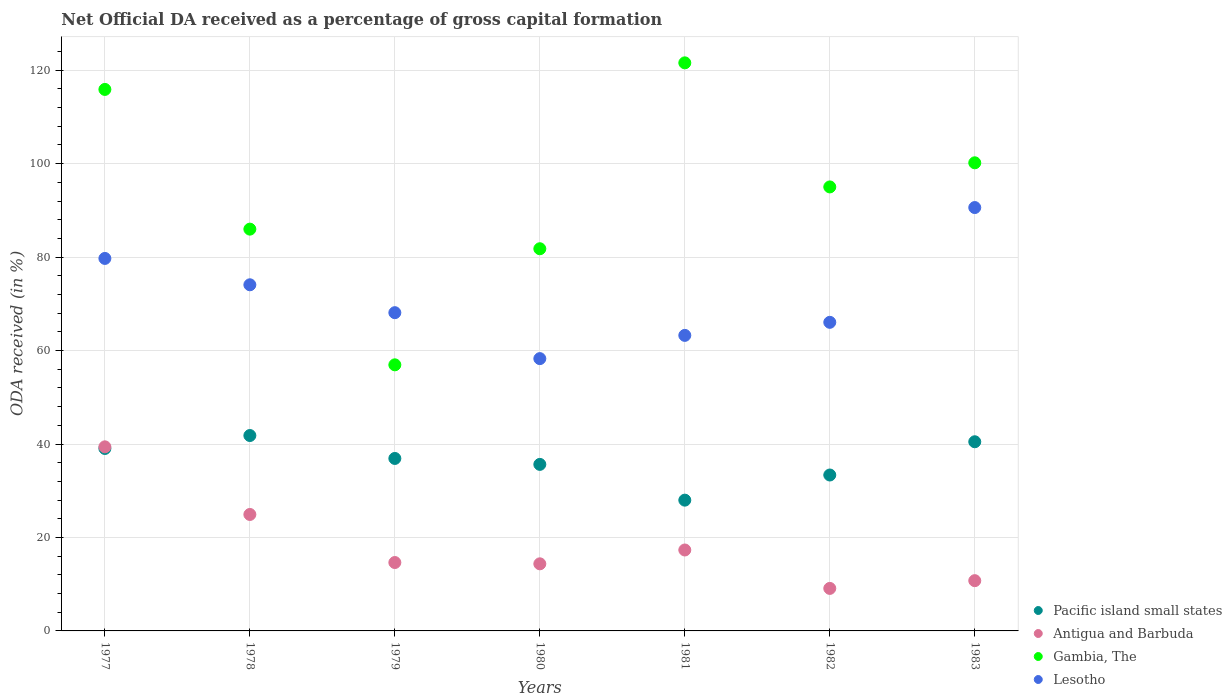What is the net ODA received in Antigua and Barbuda in 1979?
Provide a succinct answer. 14.64. Across all years, what is the maximum net ODA received in Lesotho?
Make the answer very short. 90.61. Across all years, what is the minimum net ODA received in Gambia, The?
Provide a short and direct response. 56.95. In which year was the net ODA received in Lesotho minimum?
Give a very brief answer. 1980. What is the total net ODA received in Pacific island small states in the graph?
Give a very brief answer. 255.25. What is the difference between the net ODA received in Lesotho in 1977 and that in 1980?
Keep it short and to the point. 21.44. What is the difference between the net ODA received in Lesotho in 1983 and the net ODA received in Gambia, The in 1982?
Give a very brief answer. -4.42. What is the average net ODA received in Pacific island small states per year?
Keep it short and to the point. 36.46. In the year 1980, what is the difference between the net ODA received in Lesotho and net ODA received in Pacific island small states?
Offer a very short reply. 22.64. What is the ratio of the net ODA received in Lesotho in 1978 to that in 1983?
Your answer should be compact. 0.82. What is the difference between the highest and the second highest net ODA received in Pacific island small states?
Your response must be concise. 1.33. What is the difference between the highest and the lowest net ODA received in Antigua and Barbuda?
Your response must be concise. 30.3. Is it the case that in every year, the sum of the net ODA received in Pacific island small states and net ODA received in Antigua and Barbuda  is greater than the sum of net ODA received in Gambia, The and net ODA received in Lesotho?
Provide a short and direct response. No. Is it the case that in every year, the sum of the net ODA received in Lesotho and net ODA received in Gambia, The  is greater than the net ODA received in Antigua and Barbuda?
Offer a very short reply. Yes. How many dotlines are there?
Keep it short and to the point. 4. What is the difference between two consecutive major ticks on the Y-axis?
Offer a terse response. 20. Are the values on the major ticks of Y-axis written in scientific E-notation?
Your answer should be very brief. No. Does the graph contain any zero values?
Your response must be concise. No. Where does the legend appear in the graph?
Give a very brief answer. Bottom right. How are the legend labels stacked?
Offer a terse response. Vertical. What is the title of the graph?
Offer a terse response. Net Official DA received as a percentage of gross capital formation. Does "Virgin Islands" appear as one of the legend labels in the graph?
Provide a short and direct response. No. What is the label or title of the Y-axis?
Provide a succinct answer. ODA received (in %). What is the ODA received (in %) of Pacific island small states in 1977?
Your response must be concise. 39.05. What is the ODA received (in %) in Antigua and Barbuda in 1977?
Your answer should be very brief. 39.4. What is the ODA received (in %) of Gambia, The in 1977?
Make the answer very short. 115.89. What is the ODA received (in %) in Lesotho in 1977?
Make the answer very short. 79.72. What is the ODA received (in %) of Pacific island small states in 1978?
Ensure brevity in your answer.  41.82. What is the ODA received (in %) of Antigua and Barbuda in 1978?
Offer a terse response. 24.92. What is the ODA received (in %) in Gambia, The in 1978?
Give a very brief answer. 85.99. What is the ODA received (in %) of Lesotho in 1978?
Your answer should be very brief. 74.08. What is the ODA received (in %) in Pacific island small states in 1979?
Keep it short and to the point. 36.91. What is the ODA received (in %) in Antigua and Barbuda in 1979?
Provide a short and direct response. 14.64. What is the ODA received (in %) in Gambia, The in 1979?
Offer a terse response. 56.95. What is the ODA received (in %) in Lesotho in 1979?
Make the answer very short. 68.11. What is the ODA received (in %) of Pacific island small states in 1980?
Keep it short and to the point. 35.64. What is the ODA received (in %) in Antigua and Barbuda in 1980?
Make the answer very short. 14.36. What is the ODA received (in %) in Gambia, The in 1980?
Offer a very short reply. 81.79. What is the ODA received (in %) in Lesotho in 1980?
Make the answer very short. 58.28. What is the ODA received (in %) in Pacific island small states in 1981?
Your answer should be compact. 27.99. What is the ODA received (in %) of Antigua and Barbuda in 1981?
Your answer should be very brief. 17.32. What is the ODA received (in %) in Gambia, The in 1981?
Make the answer very short. 121.58. What is the ODA received (in %) in Lesotho in 1981?
Keep it short and to the point. 63.25. What is the ODA received (in %) in Pacific island small states in 1982?
Make the answer very short. 33.37. What is the ODA received (in %) of Antigua and Barbuda in 1982?
Your answer should be very brief. 9.1. What is the ODA received (in %) in Gambia, The in 1982?
Ensure brevity in your answer.  95.02. What is the ODA received (in %) in Lesotho in 1982?
Your answer should be very brief. 66.04. What is the ODA received (in %) in Pacific island small states in 1983?
Keep it short and to the point. 40.48. What is the ODA received (in %) of Antigua and Barbuda in 1983?
Provide a succinct answer. 10.76. What is the ODA received (in %) of Gambia, The in 1983?
Your answer should be very brief. 100.18. What is the ODA received (in %) of Lesotho in 1983?
Make the answer very short. 90.61. Across all years, what is the maximum ODA received (in %) of Pacific island small states?
Provide a short and direct response. 41.82. Across all years, what is the maximum ODA received (in %) of Antigua and Barbuda?
Offer a terse response. 39.4. Across all years, what is the maximum ODA received (in %) of Gambia, The?
Provide a short and direct response. 121.58. Across all years, what is the maximum ODA received (in %) in Lesotho?
Keep it short and to the point. 90.61. Across all years, what is the minimum ODA received (in %) in Pacific island small states?
Your response must be concise. 27.99. Across all years, what is the minimum ODA received (in %) in Antigua and Barbuda?
Provide a short and direct response. 9.1. Across all years, what is the minimum ODA received (in %) of Gambia, The?
Provide a short and direct response. 56.95. Across all years, what is the minimum ODA received (in %) of Lesotho?
Your answer should be compact. 58.28. What is the total ODA received (in %) in Pacific island small states in the graph?
Keep it short and to the point. 255.25. What is the total ODA received (in %) in Antigua and Barbuda in the graph?
Ensure brevity in your answer.  130.49. What is the total ODA received (in %) of Gambia, The in the graph?
Your answer should be very brief. 657.4. What is the total ODA received (in %) of Lesotho in the graph?
Offer a very short reply. 500.08. What is the difference between the ODA received (in %) in Pacific island small states in 1977 and that in 1978?
Make the answer very short. -2.77. What is the difference between the ODA received (in %) of Antigua and Barbuda in 1977 and that in 1978?
Your answer should be compact. 14.47. What is the difference between the ODA received (in %) in Gambia, The in 1977 and that in 1978?
Ensure brevity in your answer.  29.9. What is the difference between the ODA received (in %) in Lesotho in 1977 and that in 1978?
Offer a very short reply. 5.64. What is the difference between the ODA received (in %) of Pacific island small states in 1977 and that in 1979?
Make the answer very short. 2.14. What is the difference between the ODA received (in %) in Antigua and Barbuda in 1977 and that in 1979?
Your answer should be compact. 24.76. What is the difference between the ODA received (in %) in Gambia, The in 1977 and that in 1979?
Keep it short and to the point. 58.94. What is the difference between the ODA received (in %) in Lesotho in 1977 and that in 1979?
Make the answer very short. 11.61. What is the difference between the ODA received (in %) of Pacific island small states in 1977 and that in 1980?
Your answer should be very brief. 3.41. What is the difference between the ODA received (in %) in Antigua and Barbuda in 1977 and that in 1980?
Offer a very short reply. 25.04. What is the difference between the ODA received (in %) in Gambia, The in 1977 and that in 1980?
Offer a terse response. 34.1. What is the difference between the ODA received (in %) in Lesotho in 1977 and that in 1980?
Your answer should be compact. 21.44. What is the difference between the ODA received (in %) of Pacific island small states in 1977 and that in 1981?
Make the answer very short. 11.06. What is the difference between the ODA received (in %) in Antigua and Barbuda in 1977 and that in 1981?
Your answer should be compact. 22.08. What is the difference between the ODA received (in %) of Gambia, The in 1977 and that in 1981?
Your response must be concise. -5.69. What is the difference between the ODA received (in %) in Lesotho in 1977 and that in 1981?
Ensure brevity in your answer.  16.47. What is the difference between the ODA received (in %) of Pacific island small states in 1977 and that in 1982?
Give a very brief answer. 5.68. What is the difference between the ODA received (in %) in Antigua and Barbuda in 1977 and that in 1982?
Make the answer very short. 30.3. What is the difference between the ODA received (in %) in Gambia, The in 1977 and that in 1982?
Offer a terse response. 20.87. What is the difference between the ODA received (in %) of Lesotho in 1977 and that in 1982?
Give a very brief answer. 13.67. What is the difference between the ODA received (in %) in Pacific island small states in 1977 and that in 1983?
Your answer should be compact. -1.44. What is the difference between the ODA received (in %) in Antigua and Barbuda in 1977 and that in 1983?
Your answer should be compact. 28.64. What is the difference between the ODA received (in %) in Gambia, The in 1977 and that in 1983?
Your answer should be compact. 15.7. What is the difference between the ODA received (in %) of Lesotho in 1977 and that in 1983?
Provide a succinct answer. -10.89. What is the difference between the ODA received (in %) in Pacific island small states in 1978 and that in 1979?
Your answer should be compact. 4.91. What is the difference between the ODA received (in %) of Antigua and Barbuda in 1978 and that in 1979?
Your response must be concise. 10.29. What is the difference between the ODA received (in %) of Gambia, The in 1978 and that in 1979?
Your answer should be compact. 29.04. What is the difference between the ODA received (in %) in Lesotho in 1978 and that in 1979?
Give a very brief answer. 5.97. What is the difference between the ODA received (in %) in Pacific island small states in 1978 and that in 1980?
Provide a short and direct response. 6.18. What is the difference between the ODA received (in %) of Antigua and Barbuda in 1978 and that in 1980?
Provide a succinct answer. 10.56. What is the difference between the ODA received (in %) of Gambia, The in 1978 and that in 1980?
Provide a succinct answer. 4.2. What is the difference between the ODA received (in %) of Lesotho in 1978 and that in 1980?
Provide a succinct answer. 15.8. What is the difference between the ODA received (in %) of Pacific island small states in 1978 and that in 1981?
Provide a short and direct response. 13.83. What is the difference between the ODA received (in %) of Antigua and Barbuda in 1978 and that in 1981?
Ensure brevity in your answer.  7.6. What is the difference between the ODA received (in %) in Gambia, The in 1978 and that in 1981?
Ensure brevity in your answer.  -35.59. What is the difference between the ODA received (in %) in Lesotho in 1978 and that in 1981?
Provide a succinct answer. 10.83. What is the difference between the ODA received (in %) in Pacific island small states in 1978 and that in 1982?
Ensure brevity in your answer.  8.45. What is the difference between the ODA received (in %) in Antigua and Barbuda in 1978 and that in 1982?
Your response must be concise. 15.83. What is the difference between the ODA received (in %) of Gambia, The in 1978 and that in 1982?
Ensure brevity in your answer.  -9.03. What is the difference between the ODA received (in %) in Lesotho in 1978 and that in 1982?
Offer a terse response. 8.03. What is the difference between the ODA received (in %) of Pacific island small states in 1978 and that in 1983?
Offer a very short reply. 1.33. What is the difference between the ODA received (in %) in Antigua and Barbuda in 1978 and that in 1983?
Provide a succinct answer. 14.17. What is the difference between the ODA received (in %) of Gambia, The in 1978 and that in 1983?
Your answer should be compact. -14.2. What is the difference between the ODA received (in %) in Lesotho in 1978 and that in 1983?
Give a very brief answer. -16.53. What is the difference between the ODA received (in %) of Pacific island small states in 1979 and that in 1980?
Your answer should be very brief. 1.27. What is the difference between the ODA received (in %) of Antigua and Barbuda in 1979 and that in 1980?
Your answer should be very brief. 0.28. What is the difference between the ODA received (in %) of Gambia, The in 1979 and that in 1980?
Offer a terse response. -24.84. What is the difference between the ODA received (in %) in Lesotho in 1979 and that in 1980?
Offer a very short reply. 9.83. What is the difference between the ODA received (in %) of Pacific island small states in 1979 and that in 1981?
Make the answer very short. 8.92. What is the difference between the ODA received (in %) of Antigua and Barbuda in 1979 and that in 1981?
Offer a terse response. -2.68. What is the difference between the ODA received (in %) in Gambia, The in 1979 and that in 1981?
Provide a succinct answer. -64.63. What is the difference between the ODA received (in %) of Lesotho in 1979 and that in 1981?
Offer a terse response. 4.86. What is the difference between the ODA received (in %) in Pacific island small states in 1979 and that in 1982?
Your response must be concise. 3.54. What is the difference between the ODA received (in %) of Antigua and Barbuda in 1979 and that in 1982?
Ensure brevity in your answer.  5.54. What is the difference between the ODA received (in %) of Gambia, The in 1979 and that in 1982?
Offer a very short reply. -38.07. What is the difference between the ODA received (in %) of Lesotho in 1979 and that in 1982?
Your answer should be compact. 2.07. What is the difference between the ODA received (in %) of Pacific island small states in 1979 and that in 1983?
Offer a very short reply. -3.57. What is the difference between the ODA received (in %) of Antigua and Barbuda in 1979 and that in 1983?
Provide a succinct answer. 3.88. What is the difference between the ODA received (in %) of Gambia, The in 1979 and that in 1983?
Your answer should be very brief. -43.24. What is the difference between the ODA received (in %) of Lesotho in 1979 and that in 1983?
Provide a succinct answer. -22.5. What is the difference between the ODA received (in %) of Pacific island small states in 1980 and that in 1981?
Make the answer very short. 7.65. What is the difference between the ODA received (in %) in Antigua and Barbuda in 1980 and that in 1981?
Your response must be concise. -2.96. What is the difference between the ODA received (in %) in Gambia, The in 1980 and that in 1981?
Your answer should be very brief. -39.78. What is the difference between the ODA received (in %) of Lesotho in 1980 and that in 1981?
Your response must be concise. -4.97. What is the difference between the ODA received (in %) of Pacific island small states in 1980 and that in 1982?
Your answer should be compact. 2.27. What is the difference between the ODA received (in %) in Antigua and Barbuda in 1980 and that in 1982?
Make the answer very short. 5.26. What is the difference between the ODA received (in %) in Gambia, The in 1980 and that in 1982?
Provide a short and direct response. -13.23. What is the difference between the ODA received (in %) of Lesotho in 1980 and that in 1982?
Ensure brevity in your answer.  -7.77. What is the difference between the ODA received (in %) in Pacific island small states in 1980 and that in 1983?
Your answer should be very brief. -4.84. What is the difference between the ODA received (in %) of Antigua and Barbuda in 1980 and that in 1983?
Provide a succinct answer. 3.61. What is the difference between the ODA received (in %) in Gambia, The in 1980 and that in 1983?
Provide a short and direct response. -18.39. What is the difference between the ODA received (in %) of Lesotho in 1980 and that in 1983?
Give a very brief answer. -32.33. What is the difference between the ODA received (in %) of Pacific island small states in 1981 and that in 1982?
Your answer should be very brief. -5.38. What is the difference between the ODA received (in %) of Antigua and Barbuda in 1981 and that in 1982?
Ensure brevity in your answer.  8.22. What is the difference between the ODA received (in %) in Gambia, The in 1981 and that in 1982?
Provide a succinct answer. 26.55. What is the difference between the ODA received (in %) of Lesotho in 1981 and that in 1982?
Ensure brevity in your answer.  -2.8. What is the difference between the ODA received (in %) of Pacific island small states in 1981 and that in 1983?
Offer a terse response. -12.5. What is the difference between the ODA received (in %) of Antigua and Barbuda in 1981 and that in 1983?
Offer a very short reply. 6.57. What is the difference between the ODA received (in %) in Gambia, The in 1981 and that in 1983?
Your answer should be compact. 21.39. What is the difference between the ODA received (in %) in Lesotho in 1981 and that in 1983?
Offer a very short reply. -27.36. What is the difference between the ODA received (in %) in Pacific island small states in 1982 and that in 1983?
Keep it short and to the point. -7.11. What is the difference between the ODA received (in %) of Antigua and Barbuda in 1982 and that in 1983?
Offer a terse response. -1.66. What is the difference between the ODA received (in %) of Gambia, The in 1982 and that in 1983?
Your answer should be compact. -5.16. What is the difference between the ODA received (in %) in Lesotho in 1982 and that in 1983?
Keep it short and to the point. -24.56. What is the difference between the ODA received (in %) in Pacific island small states in 1977 and the ODA received (in %) in Antigua and Barbuda in 1978?
Your response must be concise. 14.12. What is the difference between the ODA received (in %) of Pacific island small states in 1977 and the ODA received (in %) of Gambia, The in 1978?
Offer a very short reply. -46.94. What is the difference between the ODA received (in %) of Pacific island small states in 1977 and the ODA received (in %) of Lesotho in 1978?
Your answer should be very brief. -35.03. What is the difference between the ODA received (in %) of Antigua and Barbuda in 1977 and the ODA received (in %) of Gambia, The in 1978?
Provide a succinct answer. -46.59. What is the difference between the ODA received (in %) of Antigua and Barbuda in 1977 and the ODA received (in %) of Lesotho in 1978?
Your answer should be very brief. -34.68. What is the difference between the ODA received (in %) in Gambia, The in 1977 and the ODA received (in %) in Lesotho in 1978?
Provide a succinct answer. 41.81. What is the difference between the ODA received (in %) in Pacific island small states in 1977 and the ODA received (in %) in Antigua and Barbuda in 1979?
Your response must be concise. 24.41. What is the difference between the ODA received (in %) in Pacific island small states in 1977 and the ODA received (in %) in Gambia, The in 1979?
Provide a succinct answer. -17.9. What is the difference between the ODA received (in %) in Pacific island small states in 1977 and the ODA received (in %) in Lesotho in 1979?
Provide a succinct answer. -29.06. What is the difference between the ODA received (in %) of Antigua and Barbuda in 1977 and the ODA received (in %) of Gambia, The in 1979?
Make the answer very short. -17.55. What is the difference between the ODA received (in %) of Antigua and Barbuda in 1977 and the ODA received (in %) of Lesotho in 1979?
Make the answer very short. -28.71. What is the difference between the ODA received (in %) of Gambia, The in 1977 and the ODA received (in %) of Lesotho in 1979?
Your response must be concise. 47.78. What is the difference between the ODA received (in %) of Pacific island small states in 1977 and the ODA received (in %) of Antigua and Barbuda in 1980?
Provide a succinct answer. 24.69. What is the difference between the ODA received (in %) of Pacific island small states in 1977 and the ODA received (in %) of Gambia, The in 1980?
Offer a terse response. -42.75. What is the difference between the ODA received (in %) in Pacific island small states in 1977 and the ODA received (in %) in Lesotho in 1980?
Your answer should be compact. -19.23. What is the difference between the ODA received (in %) in Antigua and Barbuda in 1977 and the ODA received (in %) in Gambia, The in 1980?
Keep it short and to the point. -42.39. What is the difference between the ODA received (in %) of Antigua and Barbuda in 1977 and the ODA received (in %) of Lesotho in 1980?
Your answer should be compact. -18.88. What is the difference between the ODA received (in %) in Gambia, The in 1977 and the ODA received (in %) in Lesotho in 1980?
Offer a terse response. 57.61. What is the difference between the ODA received (in %) of Pacific island small states in 1977 and the ODA received (in %) of Antigua and Barbuda in 1981?
Your answer should be very brief. 21.73. What is the difference between the ODA received (in %) in Pacific island small states in 1977 and the ODA received (in %) in Gambia, The in 1981?
Make the answer very short. -82.53. What is the difference between the ODA received (in %) in Pacific island small states in 1977 and the ODA received (in %) in Lesotho in 1981?
Provide a short and direct response. -24.2. What is the difference between the ODA received (in %) in Antigua and Barbuda in 1977 and the ODA received (in %) in Gambia, The in 1981?
Make the answer very short. -82.18. What is the difference between the ODA received (in %) of Antigua and Barbuda in 1977 and the ODA received (in %) of Lesotho in 1981?
Give a very brief answer. -23.85. What is the difference between the ODA received (in %) in Gambia, The in 1977 and the ODA received (in %) in Lesotho in 1981?
Provide a short and direct response. 52.64. What is the difference between the ODA received (in %) of Pacific island small states in 1977 and the ODA received (in %) of Antigua and Barbuda in 1982?
Provide a short and direct response. 29.95. What is the difference between the ODA received (in %) of Pacific island small states in 1977 and the ODA received (in %) of Gambia, The in 1982?
Make the answer very short. -55.98. What is the difference between the ODA received (in %) in Pacific island small states in 1977 and the ODA received (in %) in Lesotho in 1982?
Offer a terse response. -27. What is the difference between the ODA received (in %) in Antigua and Barbuda in 1977 and the ODA received (in %) in Gambia, The in 1982?
Your answer should be very brief. -55.62. What is the difference between the ODA received (in %) in Antigua and Barbuda in 1977 and the ODA received (in %) in Lesotho in 1982?
Provide a short and direct response. -26.65. What is the difference between the ODA received (in %) of Gambia, The in 1977 and the ODA received (in %) of Lesotho in 1982?
Provide a short and direct response. 49.84. What is the difference between the ODA received (in %) in Pacific island small states in 1977 and the ODA received (in %) in Antigua and Barbuda in 1983?
Make the answer very short. 28.29. What is the difference between the ODA received (in %) in Pacific island small states in 1977 and the ODA received (in %) in Gambia, The in 1983?
Offer a very short reply. -61.14. What is the difference between the ODA received (in %) in Pacific island small states in 1977 and the ODA received (in %) in Lesotho in 1983?
Your answer should be compact. -51.56. What is the difference between the ODA received (in %) of Antigua and Barbuda in 1977 and the ODA received (in %) of Gambia, The in 1983?
Your answer should be compact. -60.79. What is the difference between the ODA received (in %) of Antigua and Barbuda in 1977 and the ODA received (in %) of Lesotho in 1983?
Give a very brief answer. -51.21. What is the difference between the ODA received (in %) of Gambia, The in 1977 and the ODA received (in %) of Lesotho in 1983?
Provide a short and direct response. 25.28. What is the difference between the ODA received (in %) in Pacific island small states in 1978 and the ODA received (in %) in Antigua and Barbuda in 1979?
Your answer should be very brief. 27.18. What is the difference between the ODA received (in %) of Pacific island small states in 1978 and the ODA received (in %) of Gambia, The in 1979?
Ensure brevity in your answer.  -15.13. What is the difference between the ODA received (in %) of Pacific island small states in 1978 and the ODA received (in %) of Lesotho in 1979?
Offer a very short reply. -26.29. What is the difference between the ODA received (in %) of Antigua and Barbuda in 1978 and the ODA received (in %) of Gambia, The in 1979?
Make the answer very short. -32.02. What is the difference between the ODA received (in %) of Antigua and Barbuda in 1978 and the ODA received (in %) of Lesotho in 1979?
Provide a short and direct response. -43.19. What is the difference between the ODA received (in %) in Gambia, The in 1978 and the ODA received (in %) in Lesotho in 1979?
Offer a terse response. 17.88. What is the difference between the ODA received (in %) in Pacific island small states in 1978 and the ODA received (in %) in Antigua and Barbuda in 1980?
Offer a terse response. 27.46. What is the difference between the ODA received (in %) of Pacific island small states in 1978 and the ODA received (in %) of Gambia, The in 1980?
Your answer should be very brief. -39.97. What is the difference between the ODA received (in %) in Pacific island small states in 1978 and the ODA received (in %) in Lesotho in 1980?
Ensure brevity in your answer.  -16.46. What is the difference between the ODA received (in %) of Antigua and Barbuda in 1978 and the ODA received (in %) of Gambia, The in 1980?
Offer a terse response. -56.87. What is the difference between the ODA received (in %) of Antigua and Barbuda in 1978 and the ODA received (in %) of Lesotho in 1980?
Provide a succinct answer. -33.35. What is the difference between the ODA received (in %) of Gambia, The in 1978 and the ODA received (in %) of Lesotho in 1980?
Make the answer very short. 27.71. What is the difference between the ODA received (in %) in Pacific island small states in 1978 and the ODA received (in %) in Antigua and Barbuda in 1981?
Provide a short and direct response. 24.5. What is the difference between the ODA received (in %) of Pacific island small states in 1978 and the ODA received (in %) of Gambia, The in 1981?
Offer a very short reply. -79.76. What is the difference between the ODA received (in %) of Pacific island small states in 1978 and the ODA received (in %) of Lesotho in 1981?
Make the answer very short. -21.43. What is the difference between the ODA received (in %) in Antigua and Barbuda in 1978 and the ODA received (in %) in Gambia, The in 1981?
Your response must be concise. -96.65. What is the difference between the ODA received (in %) in Antigua and Barbuda in 1978 and the ODA received (in %) in Lesotho in 1981?
Your answer should be compact. -38.33. What is the difference between the ODA received (in %) in Gambia, The in 1978 and the ODA received (in %) in Lesotho in 1981?
Give a very brief answer. 22.74. What is the difference between the ODA received (in %) of Pacific island small states in 1978 and the ODA received (in %) of Antigua and Barbuda in 1982?
Offer a terse response. 32.72. What is the difference between the ODA received (in %) in Pacific island small states in 1978 and the ODA received (in %) in Gambia, The in 1982?
Keep it short and to the point. -53.2. What is the difference between the ODA received (in %) of Pacific island small states in 1978 and the ODA received (in %) of Lesotho in 1982?
Offer a very short reply. -24.23. What is the difference between the ODA received (in %) in Antigua and Barbuda in 1978 and the ODA received (in %) in Gambia, The in 1982?
Your answer should be compact. -70.1. What is the difference between the ODA received (in %) in Antigua and Barbuda in 1978 and the ODA received (in %) in Lesotho in 1982?
Provide a short and direct response. -41.12. What is the difference between the ODA received (in %) in Gambia, The in 1978 and the ODA received (in %) in Lesotho in 1982?
Make the answer very short. 19.94. What is the difference between the ODA received (in %) in Pacific island small states in 1978 and the ODA received (in %) in Antigua and Barbuda in 1983?
Provide a succinct answer. 31.06. What is the difference between the ODA received (in %) of Pacific island small states in 1978 and the ODA received (in %) of Gambia, The in 1983?
Your answer should be very brief. -58.37. What is the difference between the ODA received (in %) in Pacific island small states in 1978 and the ODA received (in %) in Lesotho in 1983?
Provide a short and direct response. -48.79. What is the difference between the ODA received (in %) of Antigua and Barbuda in 1978 and the ODA received (in %) of Gambia, The in 1983?
Provide a succinct answer. -75.26. What is the difference between the ODA received (in %) of Antigua and Barbuda in 1978 and the ODA received (in %) of Lesotho in 1983?
Your answer should be compact. -65.68. What is the difference between the ODA received (in %) of Gambia, The in 1978 and the ODA received (in %) of Lesotho in 1983?
Keep it short and to the point. -4.62. What is the difference between the ODA received (in %) of Pacific island small states in 1979 and the ODA received (in %) of Antigua and Barbuda in 1980?
Make the answer very short. 22.55. What is the difference between the ODA received (in %) in Pacific island small states in 1979 and the ODA received (in %) in Gambia, The in 1980?
Keep it short and to the point. -44.88. What is the difference between the ODA received (in %) in Pacific island small states in 1979 and the ODA received (in %) in Lesotho in 1980?
Make the answer very short. -21.37. What is the difference between the ODA received (in %) in Antigua and Barbuda in 1979 and the ODA received (in %) in Gambia, The in 1980?
Provide a succinct answer. -67.15. What is the difference between the ODA received (in %) in Antigua and Barbuda in 1979 and the ODA received (in %) in Lesotho in 1980?
Keep it short and to the point. -43.64. What is the difference between the ODA received (in %) of Gambia, The in 1979 and the ODA received (in %) of Lesotho in 1980?
Make the answer very short. -1.33. What is the difference between the ODA received (in %) in Pacific island small states in 1979 and the ODA received (in %) in Antigua and Barbuda in 1981?
Provide a succinct answer. 19.59. What is the difference between the ODA received (in %) in Pacific island small states in 1979 and the ODA received (in %) in Gambia, The in 1981?
Make the answer very short. -84.66. What is the difference between the ODA received (in %) in Pacific island small states in 1979 and the ODA received (in %) in Lesotho in 1981?
Provide a succinct answer. -26.34. What is the difference between the ODA received (in %) of Antigua and Barbuda in 1979 and the ODA received (in %) of Gambia, The in 1981?
Keep it short and to the point. -106.94. What is the difference between the ODA received (in %) in Antigua and Barbuda in 1979 and the ODA received (in %) in Lesotho in 1981?
Ensure brevity in your answer.  -48.61. What is the difference between the ODA received (in %) in Gambia, The in 1979 and the ODA received (in %) in Lesotho in 1981?
Your answer should be compact. -6.3. What is the difference between the ODA received (in %) of Pacific island small states in 1979 and the ODA received (in %) of Antigua and Barbuda in 1982?
Keep it short and to the point. 27.81. What is the difference between the ODA received (in %) in Pacific island small states in 1979 and the ODA received (in %) in Gambia, The in 1982?
Your answer should be very brief. -58.11. What is the difference between the ODA received (in %) of Pacific island small states in 1979 and the ODA received (in %) of Lesotho in 1982?
Offer a very short reply. -29.13. What is the difference between the ODA received (in %) of Antigua and Barbuda in 1979 and the ODA received (in %) of Gambia, The in 1982?
Make the answer very short. -80.38. What is the difference between the ODA received (in %) in Antigua and Barbuda in 1979 and the ODA received (in %) in Lesotho in 1982?
Your response must be concise. -51.41. What is the difference between the ODA received (in %) in Gambia, The in 1979 and the ODA received (in %) in Lesotho in 1982?
Provide a short and direct response. -9.1. What is the difference between the ODA received (in %) of Pacific island small states in 1979 and the ODA received (in %) of Antigua and Barbuda in 1983?
Offer a very short reply. 26.16. What is the difference between the ODA received (in %) in Pacific island small states in 1979 and the ODA received (in %) in Gambia, The in 1983?
Offer a terse response. -63.27. What is the difference between the ODA received (in %) in Pacific island small states in 1979 and the ODA received (in %) in Lesotho in 1983?
Your response must be concise. -53.7. What is the difference between the ODA received (in %) in Antigua and Barbuda in 1979 and the ODA received (in %) in Gambia, The in 1983?
Your answer should be very brief. -85.55. What is the difference between the ODA received (in %) of Antigua and Barbuda in 1979 and the ODA received (in %) of Lesotho in 1983?
Ensure brevity in your answer.  -75.97. What is the difference between the ODA received (in %) of Gambia, The in 1979 and the ODA received (in %) of Lesotho in 1983?
Provide a succinct answer. -33.66. What is the difference between the ODA received (in %) in Pacific island small states in 1980 and the ODA received (in %) in Antigua and Barbuda in 1981?
Your answer should be very brief. 18.32. What is the difference between the ODA received (in %) of Pacific island small states in 1980 and the ODA received (in %) of Gambia, The in 1981?
Make the answer very short. -85.94. What is the difference between the ODA received (in %) in Pacific island small states in 1980 and the ODA received (in %) in Lesotho in 1981?
Provide a succinct answer. -27.61. What is the difference between the ODA received (in %) in Antigua and Barbuda in 1980 and the ODA received (in %) in Gambia, The in 1981?
Offer a terse response. -107.21. What is the difference between the ODA received (in %) in Antigua and Barbuda in 1980 and the ODA received (in %) in Lesotho in 1981?
Offer a very short reply. -48.89. What is the difference between the ODA received (in %) of Gambia, The in 1980 and the ODA received (in %) of Lesotho in 1981?
Ensure brevity in your answer.  18.54. What is the difference between the ODA received (in %) in Pacific island small states in 1980 and the ODA received (in %) in Antigua and Barbuda in 1982?
Your answer should be compact. 26.54. What is the difference between the ODA received (in %) in Pacific island small states in 1980 and the ODA received (in %) in Gambia, The in 1982?
Ensure brevity in your answer.  -59.38. What is the difference between the ODA received (in %) in Pacific island small states in 1980 and the ODA received (in %) in Lesotho in 1982?
Keep it short and to the point. -30.4. What is the difference between the ODA received (in %) in Antigua and Barbuda in 1980 and the ODA received (in %) in Gambia, The in 1982?
Offer a very short reply. -80.66. What is the difference between the ODA received (in %) of Antigua and Barbuda in 1980 and the ODA received (in %) of Lesotho in 1982?
Give a very brief answer. -51.68. What is the difference between the ODA received (in %) of Gambia, The in 1980 and the ODA received (in %) of Lesotho in 1982?
Provide a short and direct response. 15.75. What is the difference between the ODA received (in %) in Pacific island small states in 1980 and the ODA received (in %) in Antigua and Barbuda in 1983?
Offer a terse response. 24.88. What is the difference between the ODA received (in %) in Pacific island small states in 1980 and the ODA received (in %) in Gambia, The in 1983?
Your answer should be compact. -64.54. What is the difference between the ODA received (in %) of Pacific island small states in 1980 and the ODA received (in %) of Lesotho in 1983?
Provide a succinct answer. -54.97. What is the difference between the ODA received (in %) of Antigua and Barbuda in 1980 and the ODA received (in %) of Gambia, The in 1983?
Make the answer very short. -85.82. What is the difference between the ODA received (in %) in Antigua and Barbuda in 1980 and the ODA received (in %) in Lesotho in 1983?
Keep it short and to the point. -76.25. What is the difference between the ODA received (in %) in Gambia, The in 1980 and the ODA received (in %) in Lesotho in 1983?
Offer a terse response. -8.81. What is the difference between the ODA received (in %) in Pacific island small states in 1981 and the ODA received (in %) in Antigua and Barbuda in 1982?
Ensure brevity in your answer.  18.89. What is the difference between the ODA received (in %) of Pacific island small states in 1981 and the ODA received (in %) of Gambia, The in 1982?
Keep it short and to the point. -67.03. What is the difference between the ODA received (in %) of Pacific island small states in 1981 and the ODA received (in %) of Lesotho in 1982?
Keep it short and to the point. -38.06. What is the difference between the ODA received (in %) of Antigua and Barbuda in 1981 and the ODA received (in %) of Gambia, The in 1982?
Make the answer very short. -77.7. What is the difference between the ODA received (in %) of Antigua and Barbuda in 1981 and the ODA received (in %) of Lesotho in 1982?
Make the answer very short. -48.72. What is the difference between the ODA received (in %) of Gambia, The in 1981 and the ODA received (in %) of Lesotho in 1982?
Offer a very short reply. 55.53. What is the difference between the ODA received (in %) in Pacific island small states in 1981 and the ODA received (in %) in Antigua and Barbuda in 1983?
Your answer should be very brief. 17.23. What is the difference between the ODA received (in %) in Pacific island small states in 1981 and the ODA received (in %) in Gambia, The in 1983?
Give a very brief answer. -72.2. What is the difference between the ODA received (in %) in Pacific island small states in 1981 and the ODA received (in %) in Lesotho in 1983?
Provide a succinct answer. -62.62. What is the difference between the ODA received (in %) of Antigua and Barbuda in 1981 and the ODA received (in %) of Gambia, The in 1983?
Give a very brief answer. -82.86. What is the difference between the ODA received (in %) in Antigua and Barbuda in 1981 and the ODA received (in %) in Lesotho in 1983?
Give a very brief answer. -73.29. What is the difference between the ODA received (in %) of Gambia, The in 1981 and the ODA received (in %) of Lesotho in 1983?
Give a very brief answer. 30.97. What is the difference between the ODA received (in %) in Pacific island small states in 1982 and the ODA received (in %) in Antigua and Barbuda in 1983?
Offer a terse response. 22.61. What is the difference between the ODA received (in %) of Pacific island small states in 1982 and the ODA received (in %) of Gambia, The in 1983?
Provide a succinct answer. -66.82. What is the difference between the ODA received (in %) in Pacific island small states in 1982 and the ODA received (in %) in Lesotho in 1983?
Keep it short and to the point. -57.24. What is the difference between the ODA received (in %) in Antigua and Barbuda in 1982 and the ODA received (in %) in Gambia, The in 1983?
Provide a short and direct response. -91.09. What is the difference between the ODA received (in %) in Antigua and Barbuda in 1982 and the ODA received (in %) in Lesotho in 1983?
Keep it short and to the point. -81.51. What is the difference between the ODA received (in %) in Gambia, The in 1982 and the ODA received (in %) in Lesotho in 1983?
Provide a short and direct response. 4.42. What is the average ODA received (in %) of Pacific island small states per year?
Provide a short and direct response. 36.46. What is the average ODA received (in %) in Antigua and Barbuda per year?
Your answer should be very brief. 18.64. What is the average ODA received (in %) of Gambia, The per year?
Your answer should be compact. 93.91. What is the average ODA received (in %) in Lesotho per year?
Your response must be concise. 71.44. In the year 1977, what is the difference between the ODA received (in %) in Pacific island small states and ODA received (in %) in Antigua and Barbuda?
Your response must be concise. -0.35. In the year 1977, what is the difference between the ODA received (in %) of Pacific island small states and ODA received (in %) of Gambia, The?
Offer a very short reply. -76.84. In the year 1977, what is the difference between the ODA received (in %) of Pacific island small states and ODA received (in %) of Lesotho?
Your response must be concise. -40.67. In the year 1977, what is the difference between the ODA received (in %) of Antigua and Barbuda and ODA received (in %) of Gambia, The?
Your answer should be very brief. -76.49. In the year 1977, what is the difference between the ODA received (in %) in Antigua and Barbuda and ODA received (in %) in Lesotho?
Offer a terse response. -40.32. In the year 1977, what is the difference between the ODA received (in %) of Gambia, The and ODA received (in %) of Lesotho?
Make the answer very short. 36.17. In the year 1978, what is the difference between the ODA received (in %) in Pacific island small states and ODA received (in %) in Antigua and Barbuda?
Your response must be concise. 16.89. In the year 1978, what is the difference between the ODA received (in %) in Pacific island small states and ODA received (in %) in Gambia, The?
Make the answer very short. -44.17. In the year 1978, what is the difference between the ODA received (in %) of Pacific island small states and ODA received (in %) of Lesotho?
Your response must be concise. -32.26. In the year 1978, what is the difference between the ODA received (in %) of Antigua and Barbuda and ODA received (in %) of Gambia, The?
Keep it short and to the point. -61.06. In the year 1978, what is the difference between the ODA received (in %) in Antigua and Barbuda and ODA received (in %) in Lesotho?
Offer a very short reply. -49.15. In the year 1978, what is the difference between the ODA received (in %) in Gambia, The and ODA received (in %) in Lesotho?
Your answer should be compact. 11.91. In the year 1979, what is the difference between the ODA received (in %) in Pacific island small states and ODA received (in %) in Antigua and Barbuda?
Give a very brief answer. 22.27. In the year 1979, what is the difference between the ODA received (in %) of Pacific island small states and ODA received (in %) of Gambia, The?
Your response must be concise. -20.04. In the year 1979, what is the difference between the ODA received (in %) of Pacific island small states and ODA received (in %) of Lesotho?
Make the answer very short. -31.2. In the year 1979, what is the difference between the ODA received (in %) of Antigua and Barbuda and ODA received (in %) of Gambia, The?
Offer a very short reply. -42.31. In the year 1979, what is the difference between the ODA received (in %) of Antigua and Barbuda and ODA received (in %) of Lesotho?
Offer a very short reply. -53.47. In the year 1979, what is the difference between the ODA received (in %) in Gambia, The and ODA received (in %) in Lesotho?
Your answer should be very brief. -11.16. In the year 1980, what is the difference between the ODA received (in %) in Pacific island small states and ODA received (in %) in Antigua and Barbuda?
Your answer should be very brief. 21.28. In the year 1980, what is the difference between the ODA received (in %) of Pacific island small states and ODA received (in %) of Gambia, The?
Offer a terse response. -46.15. In the year 1980, what is the difference between the ODA received (in %) in Pacific island small states and ODA received (in %) in Lesotho?
Ensure brevity in your answer.  -22.64. In the year 1980, what is the difference between the ODA received (in %) in Antigua and Barbuda and ODA received (in %) in Gambia, The?
Keep it short and to the point. -67.43. In the year 1980, what is the difference between the ODA received (in %) in Antigua and Barbuda and ODA received (in %) in Lesotho?
Your answer should be very brief. -43.92. In the year 1980, what is the difference between the ODA received (in %) in Gambia, The and ODA received (in %) in Lesotho?
Keep it short and to the point. 23.51. In the year 1981, what is the difference between the ODA received (in %) in Pacific island small states and ODA received (in %) in Antigua and Barbuda?
Provide a short and direct response. 10.67. In the year 1981, what is the difference between the ODA received (in %) of Pacific island small states and ODA received (in %) of Gambia, The?
Your response must be concise. -93.59. In the year 1981, what is the difference between the ODA received (in %) of Pacific island small states and ODA received (in %) of Lesotho?
Provide a succinct answer. -35.26. In the year 1981, what is the difference between the ODA received (in %) in Antigua and Barbuda and ODA received (in %) in Gambia, The?
Offer a very short reply. -104.25. In the year 1981, what is the difference between the ODA received (in %) in Antigua and Barbuda and ODA received (in %) in Lesotho?
Give a very brief answer. -45.93. In the year 1981, what is the difference between the ODA received (in %) in Gambia, The and ODA received (in %) in Lesotho?
Offer a terse response. 58.33. In the year 1982, what is the difference between the ODA received (in %) of Pacific island small states and ODA received (in %) of Antigua and Barbuda?
Keep it short and to the point. 24.27. In the year 1982, what is the difference between the ODA received (in %) of Pacific island small states and ODA received (in %) of Gambia, The?
Ensure brevity in your answer.  -61.65. In the year 1982, what is the difference between the ODA received (in %) in Pacific island small states and ODA received (in %) in Lesotho?
Offer a terse response. -32.68. In the year 1982, what is the difference between the ODA received (in %) in Antigua and Barbuda and ODA received (in %) in Gambia, The?
Provide a succinct answer. -85.92. In the year 1982, what is the difference between the ODA received (in %) in Antigua and Barbuda and ODA received (in %) in Lesotho?
Your response must be concise. -56.95. In the year 1982, what is the difference between the ODA received (in %) of Gambia, The and ODA received (in %) of Lesotho?
Give a very brief answer. 28.98. In the year 1983, what is the difference between the ODA received (in %) of Pacific island small states and ODA received (in %) of Antigua and Barbuda?
Offer a terse response. 29.73. In the year 1983, what is the difference between the ODA received (in %) of Pacific island small states and ODA received (in %) of Gambia, The?
Provide a succinct answer. -59.7. In the year 1983, what is the difference between the ODA received (in %) of Pacific island small states and ODA received (in %) of Lesotho?
Provide a short and direct response. -50.12. In the year 1983, what is the difference between the ODA received (in %) in Antigua and Barbuda and ODA received (in %) in Gambia, The?
Ensure brevity in your answer.  -89.43. In the year 1983, what is the difference between the ODA received (in %) in Antigua and Barbuda and ODA received (in %) in Lesotho?
Provide a short and direct response. -79.85. In the year 1983, what is the difference between the ODA received (in %) of Gambia, The and ODA received (in %) of Lesotho?
Your answer should be very brief. 9.58. What is the ratio of the ODA received (in %) in Pacific island small states in 1977 to that in 1978?
Your answer should be compact. 0.93. What is the ratio of the ODA received (in %) of Antigua and Barbuda in 1977 to that in 1978?
Provide a short and direct response. 1.58. What is the ratio of the ODA received (in %) in Gambia, The in 1977 to that in 1978?
Offer a very short reply. 1.35. What is the ratio of the ODA received (in %) of Lesotho in 1977 to that in 1978?
Your answer should be very brief. 1.08. What is the ratio of the ODA received (in %) of Pacific island small states in 1977 to that in 1979?
Your answer should be very brief. 1.06. What is the ratio of the ODA received (in %) in Antigua and Barbuda in 1977 to that in 1979?
Give a very brief answer. 2.69. What is the ratio of the ODA received (in %) of Gambia, The in 1977 to that in 1979?
Provide a succinct answer. 2.04. What is the ratio of the ODA received (in %) of Lesotho in 1977 to that in 1979?
Make the answer very short. 1.17. What is the ratio of the ODA received (in %) in Pacific island small states in 1977 to that in 1980?
Your response must be concise. 1.1. What is the ratio of the ODA received (in %) of Antigua and Barbuda in 1977 to that in 1980?
Give a very brief answer. 2.74. What is the ratio of the ODA received (in %) of Gambia, The in 1977 to that in 1980?
Make the answer very short. 1.42. What is the ratio of the ODA received (in %) of Lesotho in 1977 to that in 1980?
Offer a terse response. 1.37. What is the ratio of the ODA received (in %) of Pacific island small states in 1977 to that in 1981?
Your answer should be very brief. 1.4. What is the ratio of the ODA received (in %) in Antigua and Barbuda in 1977 to that in 1981?
Give a very brief answer. 2.27. What is the ratio of the ODA received (in %) of Gambia, The in 1977 to that in 1981?
Your response must be concise. 0.95. What is the ratio of the ODA received (in %) of Lesotho in 1977 to that in 1981?
Your answer should be compact. 1.26. What is the ratio of the ODA received (in %) in Pacific island small states in 1977 to that in 1982?
Your answer should be very brief. 1.17. What is the ratio of the ODA received (in %) in Antigua and Barbuda in 1977 to that in 1982?
Your answer should be very brief. 4.33. What is the ratio of the ODA received (in %) in Gambia, The in 1977 to that in 1982?
Give a very brief answer. 1.22. What is the ratio of the ODA received (in %) in Lesotho in 1977 to that in 1982?
Ensure brevity in your answer.  1.21. What is the ratio of the ODA received (in %) in Pacific island small states in 1977 to that in 1983?
Keep it short and to the point. 0.96. What is the ratio of the ODA received (in %) of Antigua and Barbuda in 1977 to that in 1983?
Your answer should be compact. 3.66. What is the ratio of the ODA received (in %) in Gambia, The in 1977 to that in 1983?
Provide a short and direct response. 1.16. What is the ratio of the ODA received (in %) of Lesotho in 1977 to that in 1983?
Make the answer very short. 0.88. What is the ratio of the ODA received (in %) in Pacific island small states in 1978 to that in 1979?
Ensure brevity in your answer.  1.13. What is the ratio of the ODA received (in %) of Antigua and Barbuda in 1978 to that in 1979?
Provide a succinct answer. 1.7. What is the ratio of the ODA received (in %) of Gambia, The in 1978 to that in 1979?
Make the answer very short. 1.51. What is the ratio of the ODA received (in %) in Lesotho in 1978 to that in 1979?
Make the answer very short. 1.09. What is the ratio of the ODA received (in %) in Pacific island small states in 1978 to that in 1980?
Provide a succinct answer. 1.17. What is the ratio of the ODA received (in %) in Antigua and Barbuda in 1978 to that in 1980?
Your answer should be compact. 1.74. What is the ratio of the ODA received (in %) in Gambia, The in 1978 to that in 1980?
Your response must be concise. 1.05. What is the ratio of the ODA received (in %) of Lesotho in 1978 to that in 1980?
Provide a short and direct response. 1.27. What is the ratio of the ODA received (in %) of Pacific island small states in 1978 to that in 1981?
Your response must be concise. 1.49. What is the ratio of the ODA received (in %) in Antigua and Barbuda in 1978 to that in 1981?
Provide a short and direct response. 1.44. What is the ratio of the ODA received (in %) of Gambia, The in 1978 to that in 1981?
Make the answer very short. 0.71. What is the ratio of the ODA received (in %) of Lesotho in 1978 to that in 1981?
Provide a short and direct response. 1.17. What is the ratio of the ODA received (in %) of Pacific island small states in 1978 to that in 1982?
Give a very brief answer. 1.25. What is the ratio of the ODA received (in %) in Antigua and Barbuda in 1978 to that in 1982?
Provide a short and direct response. 2.74. What is the ratio of the ODA received (in %) of Gambia, The in 1978 to that in 1982?
Provide a succinct answer. 0.9. What is the ratio of the ODA received (in %) in Lesotho in 1978 to that in 1982?
Your response must be concise. 1.12. What is the ratio of the ODA received (in %) in Pacific island small states in 1978 to that in 1983?
Offer a very short reply. 1.03. What is the ratio of the ODA received (in %) in Antigua and Barbuda in 1978 to that in 1983?
Provide a short and direct response. 2.32. What is the ratio of the ODA received (in %) in Gambia, The in 1978 to that in 1983?
Ensure brevity in your answer.  0.86. What is the ratio of the ODA received (in %) of Lesotho in 1978 to that in 1983?
Make the answer very short. 0.82. What is the ratio of the ODA received (in %) of Pacific island small states in 1979 to that in 1980?
Your answer should be very brief. 1.04. What is the ratio of the ODA received (in %) in Antigua and Barbuda in 1979 to that in 1980?
Make the answer very short. 1.02. What is the ratio of the ODA received (in %) in Gambia, The in 1979 to that in 1980?
Ensure brevity in your answer.  0.7. What is the ratio of the ODA received (in %) of Lesotho in 1979 to that in 1980?
Ensure brevity in your answer.  1.17. What is the ratio of the ODA received (in %) in Pacific island small states in 1979 to that in 1981?
Provide a succinct answer. 1.32. What is the ratio of the ODA received (in %) of Antigua and Barbuda in 1979 to that in 1981?
Offer a terse response. 0.85. What is the ratio of the ODA received (in %) of Gambia, The in 1979 to that in 1981?
Make the answer very short. 0.47. What is the ratio of the ODA received (in %) in Pacific island small states in 1979 to that in 1982?
Ensure brevity in your answer.  1.11. What is the ratio of the ODA received (in %) in Antigua and Barbuda in 1979 to that in 1982?
Your answer should be compact. 1.61. What is the ratio of the ODA received (in %) in Gambia, The in 1979 to that in 1982?
Your response must be concise. 0.6. What is the ratio of the ODA received (in %) of Lesotho in 1979 to that in 1982?
Your answer should be compact. 1.03. What is the ratio of the ODA received (in %) of Pacific island small states in 1979 to that in 1983?
Provide a short and direct response. 0.91. What is the ratio of the ODA received (in %) of Antigua and Barbuda in 1979 to that in 1983?
Keep it short and to the point. 1.36. What is the ratio of the ODA received (in %) of Gambia, The in 1979 to that in 1983?
Give a very brief answer. 0.57. What is the ratio of the ODA received (in %) of Lesotho in 1979 to that in 1983?
Provide a succinct answer. 0.75. What is the ratio of the ODA received (in %) of Pacific island small states in 1980 to that in 1981?
Give a very brief answer. 1.27. What is the ratio of the ODA received (in %) of Antigua and Barbuda in 1980 to that in 1981?
Give a very brief answer. 0.83. What is the ratio of the ODA received (in %) of Gambia, The in 1980 to that in 1981?
Offer a very short reply. 0.67. What is the ratio of the ODA received (in %) of Lesotho in 1980 to that in 1981?
Give a very brief answer. 0.92. What is the ratio of the ODA received (in %) in Pacific island small states in 1980 to that in 1982?
Provide a succinct answer. 1.07. What is the ratio of the ODA received (in %) in Antigua and Barbuda in 1980 to that in 1982?
Provide a short and direct response. 1.58. What is the ratio of the ODA received (in %) in Gambia, The in 1980 to that in 1982?
Keep it short and to the point. 0.86. What is the ratio of the ODA received (in %) of Lesotho in 1980 to that in 1982?
Offer a terse response. 0.88. What is the ratio of the ODA received (in %) in Pacific island small states in 1980 to that in 1983?
Your answer should be very brief. 0.88. What is the ratio of the ODA received (in %) in Antigua and Barbuda in 1980 to that in 1983?
Keep it short and to the point. 1.34. What is the ratio of the ODA received (in %) in Gambia, The in 1980 to that in 1983?
Provide a succinct answer. 0.82. What is the ratio of the ODA received (in %) in Lesotho in 1980 to that in 1983?
Offer a terse response. 0.64. What is the ratio of the ODA received (in %) of Pacific island small states in 1981 to that in 1982?
Give a very brief answer. 0.84. What is the ratio of the ODA received (in %) in Antigua and Barbuda in 1981 to that in 1982?
Your response must be concise. 1.9. What is the ratio of the ODA received (in %) in Gambia, The in 1981 to that in 1982?
Keep it short and to the point. 1.28. What is the ratio of the ODA received (in %) of Lesotho in 1981 to that in 1982?
Make the answer very short. 0.96. What is the ratio of the ODA received (in %) of Pacific island small states in 1981 to that in 1983?
Give a very brief answer. 0.69. What is the ratio of the ODA received (in %) of Antigua and Barbuda in 1981 to that in 1983?
Offer a terse response. 1.61. What is the ratio of the ODA received (in %) in Gambia, The in 1981 to that in 1983?
Provide a succinct answer. 1.21. What is the ratio of the ODA received (in %) in Lesotho in 1981 to that in 1983?
Your answer should be very brief. 0.7. What is the ratio of the ODA received (in %) in Pacific island small states in 1982 to that in 1983?
Offer a very short reply. 0.82. What is the ratio of the ODA received (in %) of Antigua and Barbuda in 1982 to that in 1983?
Your response must be concise. 0.85. What is the ratio of the ODA received (in %) in Gambia, The in 1982 to that in 1983?
Offer a terse response. 0.95. What is the ratio of the ODA received (in %) of Lesotho in 1982 to that in 1983?
Make the answer very short. 0.73. What is the difference between the highest and the second highest ODA received (in %) in Pacific island small states?
Offer a terse response. 1.33. What is the difference between the highest and the second highest ODA received (in %) of Antigua and Barbuda?
Your answer should be very brief. 14.47. What is the difference between the highest and the second highest ODA received (in %) in Gambia, The?
Keep it short and to the point. 5.69. What is the difference between the highest and the second highest ODA received (in %) in Lesotho?
Offer a terse response. 10.89. What is the difference between the highest and the lowest ODA received (in %) in Pacific island small states?
Offer a very short reply. 13.83. What is the difference between the highest and the lowest ODA received (in %) in Antigua and Barbuda?
Your answer should be very brief. 30.3. What is the difference between the highest and the lowest ODA received (in %) in Gambia, The?
Give a very brief answer. 64.63. What is the difference between the highest and the lowest ODA received (in %) of Lesotho?
Make the answer very short. 32.33. 